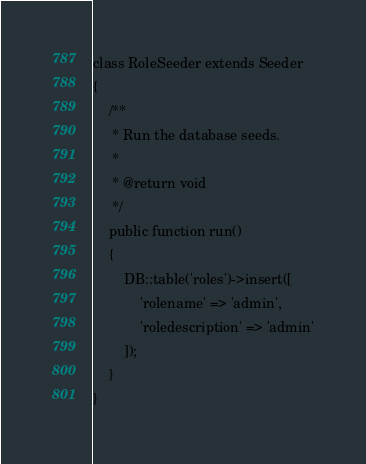Convert code to text. <code><loc_0><loc_0><loc_500><loc_500><_PHP_>class RoleSeeder extends Seeder
{
    /**
     * Run the database seeds.
     *
     * @return void
     */
    public function run()
    {
        DB::table('roles')->insert([
            'rolename' => 'admin',
            'roledescription' => 'admin'
        ]);
    }
}
</code> 